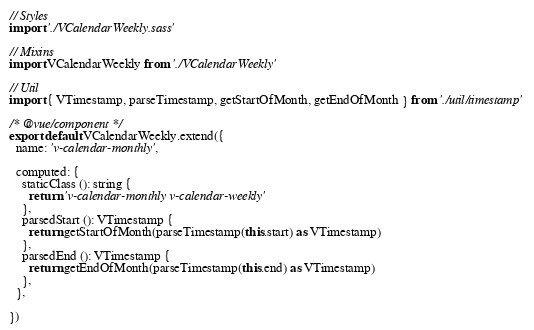<code> <loc_0><loc_0><loc_500><loc_500><_TypeScript_>// Styles
import './VCalendarWeekly.sass'

// Mixins
import VCalendarWeekly from './VCalendarWeekly'

// Util
import { VTimestamp, parseTimestamp, getStartOfMonth, getEndOfMonth } from './util/timestamp'

/* @vue/component */
export default VCalendarWeekly.extend({
  name: 'v-calendar-monthly',

  computed: {
    staticClass (): string {
      return 'v-calendar-monthly v-calendar-weekly'
    },
    parsedStart (): VTimestamp {
      return getStartOfMonth(parseTimestamp(this.start) as VTimestamp)
    },
    parsedEnd (): VTimestamp {
      return getEndOfMonth(parseTimestamp(this.end) as VTimestamp)
    },
  },

})
</code> 